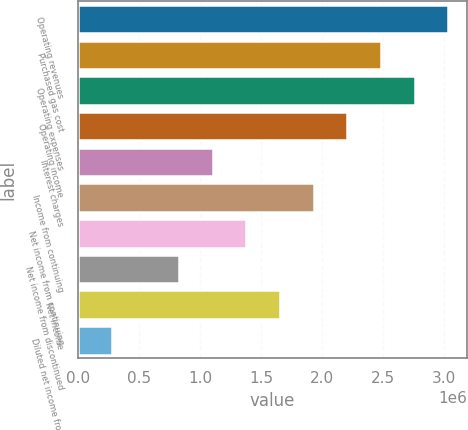<chart> <loc_0><loc_0><loc_500><loc_500><bar_chart><fcel>Operating revenues<fcel>Purchased gas cost<fcel>Operating expenses<fcel>Operating income<fcel>Interest charges<fcel>Income from continuing<fcel>Net income from continuing<fcel>Net income from discontinued<fcel>Net income<fcel>Diluted net income from<nl><fcel>3.03571e+06<fcel>2.48376e+06<fcel>2.75974e+06<fcel>2.20779e+06<fcel>1.10389e+06<fcel>1.93181e+06<fcel>1.37987e+06<fcel>827921<fcel>1.65584e+06<fcel>275974<nl></chart> 